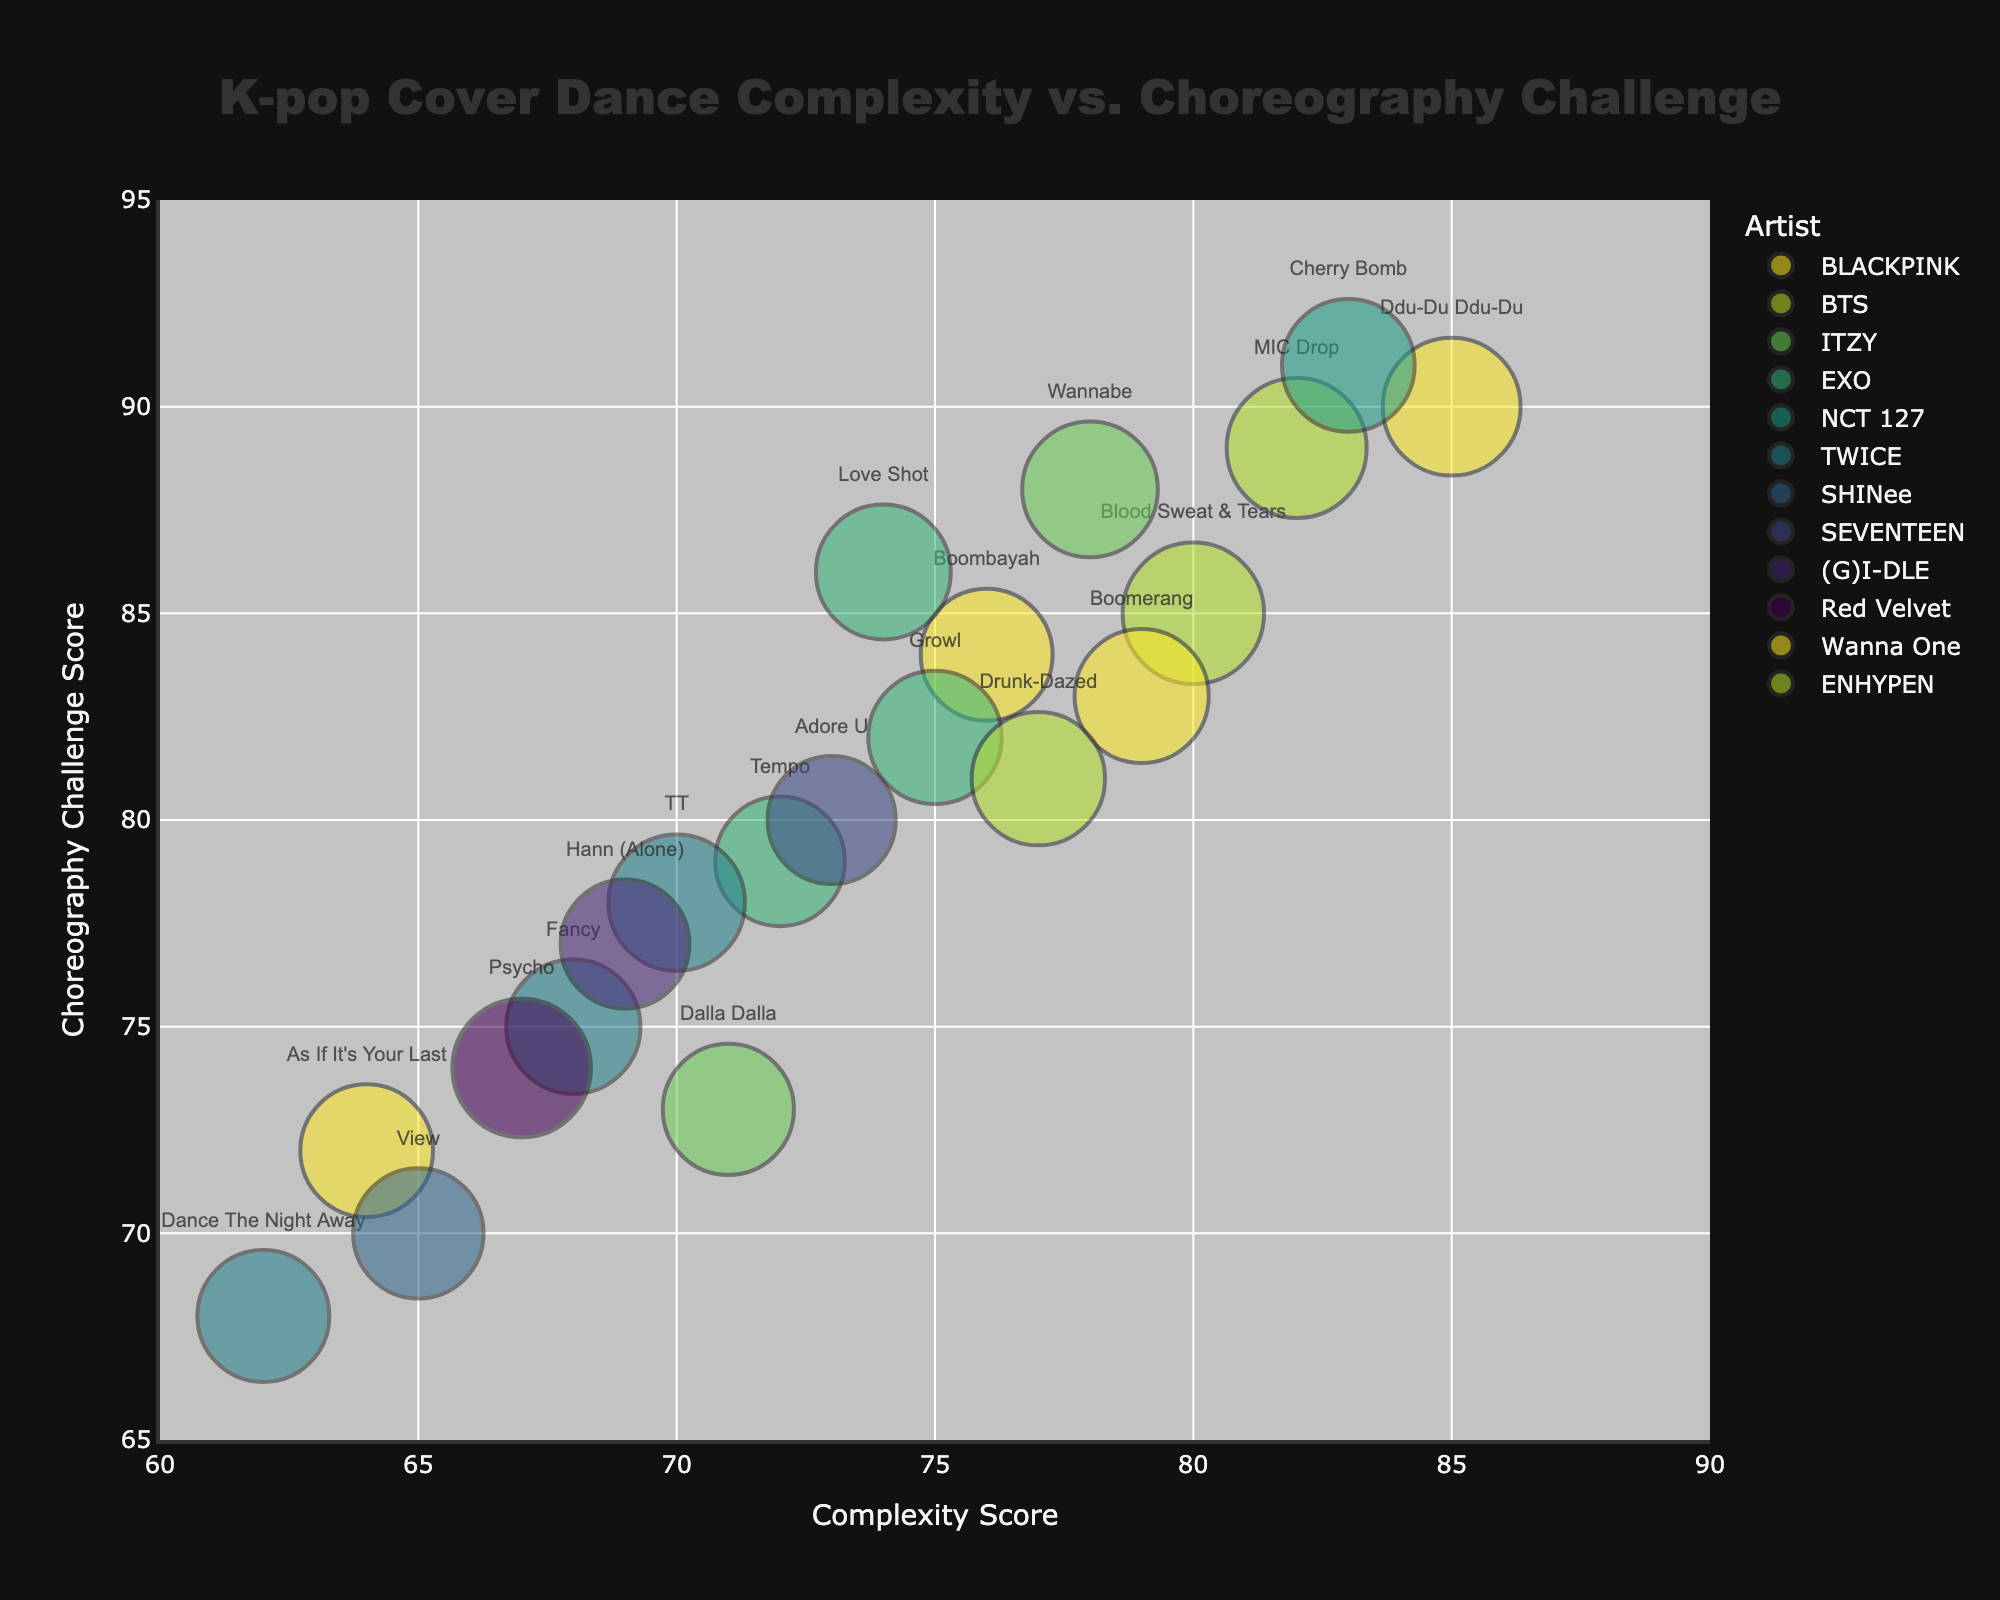What is the title of the chart? The title is usually located at the top of the chart. Read the text in that position. The title says "K-pop Cover Dance Complexity vs. Choreography Challenge".
Answer: K-pop Cover Dance Complexity vs. Choreography Challenge Which song has the highest popularity rating? Check the size of the bubbles. Larger bubbles indicate higher popularity. "Blood Sweat & Tears" by BTS has the largest bubble, indicating it has the highest popularity rating of 100.
Answer: Blood Sweat & Tears What is the complexity score of "MIC Drop" by BTS? Locate the bubble labeled "MIC Drop". The complexity score is on the x-axis. The bubble is located at a Complexity of 82.
Answer: 82 How does the choreography challenge score of "Ddu-Du Ddu-Du" compare to "Cherry Bomb"? Find both bubbles and compare their positions on the y-axis. "Ddu-Du Ddu-Du" has a score of 90, and "Cherry Bomb" has a score of 91. So, "Cherry Bomb" has a slightly higher choreography challenge score than "Ddu-Du Ddu-Du".
Answer: Cherry Bomb is higher Which group has the most songs listed in the chart, and how many songs do they have? Count the number of unique bubbles for each artist. BLACKPINK has the most songs, with a total of 3 ("Ddu-Du Ddu-Du", "Boombayah", "As If It's Your Last").
Answer: BLACKPINK, 3 What is the average complexity score of the songs by TWICE? Locate all TWICE bubbles and note their complexity scores: 70 ("TT"), 68 ("Fancy"), 62 ("Dance The Night Away"). Average these scores: (70 + 68 + 62) / 3 = 66.67.
Answer: 66.67 Which song has the lowest choreography challenge score? Identify the bubble located lowest on the y-axis. "Dance The Night Away" by TWICE is the lowest with a choreography challenge score of 68.
Answer: Dance The Night Away Is there any song with an equal complexity and choreography challenge score? Check for any bubble located on where both axes intersect equally. There is no such bubble in this dataset, so no song has equal complexity and choreography challenge scores.
Answer: No What is the overall trend between complexity and choreography challenge in this chart? Observe the general direction in which most bubbles are positioned. As complexity scores increase, choreography challenge scores also tend to increase, indicating a positive correlation.
Answer: Positive correlation 